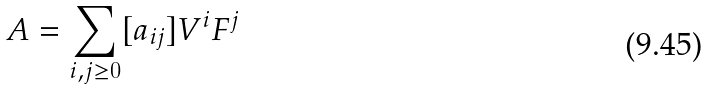Convert formula to latex. <formula><loc_0><loc_0><loc_500><loc_500>A = \sum _ { i , j \geq 0 } [ a _ { i j } ] V ^ { i } F ^ { j }</formula> 